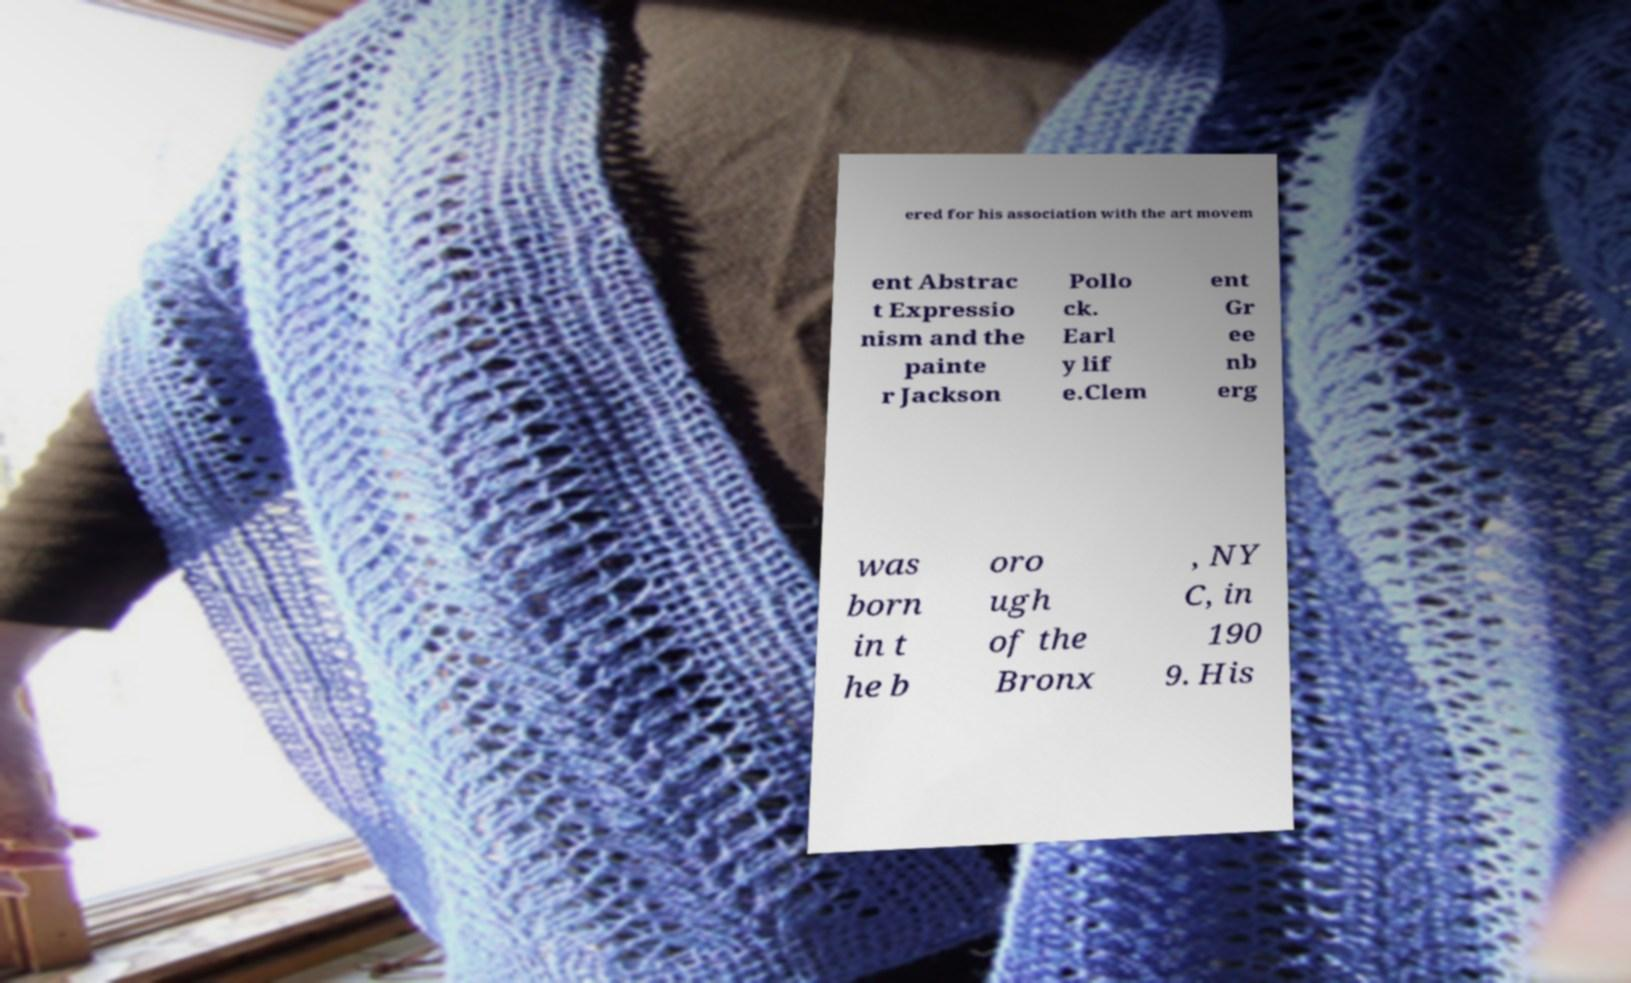Please identify and transcribe the text found in this image. ered for his association with the art movem ent Abstrac t Expressio nism and the painte r Jackson Pollo ck. Earl y lif e.Clem ent Gr ee nb erg was born in t he b oro ugh of the Bronx , NY C, in 190 9. His 